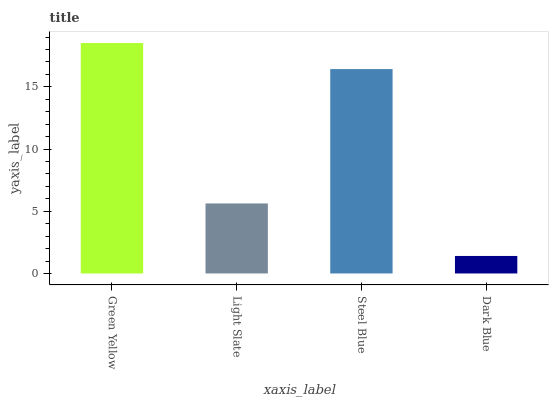Is Dark Blue the minimum?
Answer yes or no. Yes. Is Green Yellow the maximum?
Answer yes or no. Yes. Is Light Slate the minimum?
Answer yes or no. No. Is Light Slate the maximum?
Answer yes or no. No. Is Green Yellow greater than Light Slate?
Answer yes or no. Yes. Is Light Slate less than Green Yellow?
Answer yes or no. Yes. Is Light Slate greater than Green Yellow?
Answer yes or no. No. Is Green Yellow less than Light Slate?
Answer yes or no. No. Is Steel Blue the high median?
Answer yes or no. Yes. Is Light Slate the low median?
Answer yes or no. Yes. Is Dark Blue the high median?
Answer yes or no. No. Is Dark Blue the low median?
Answer yes or no. No. 